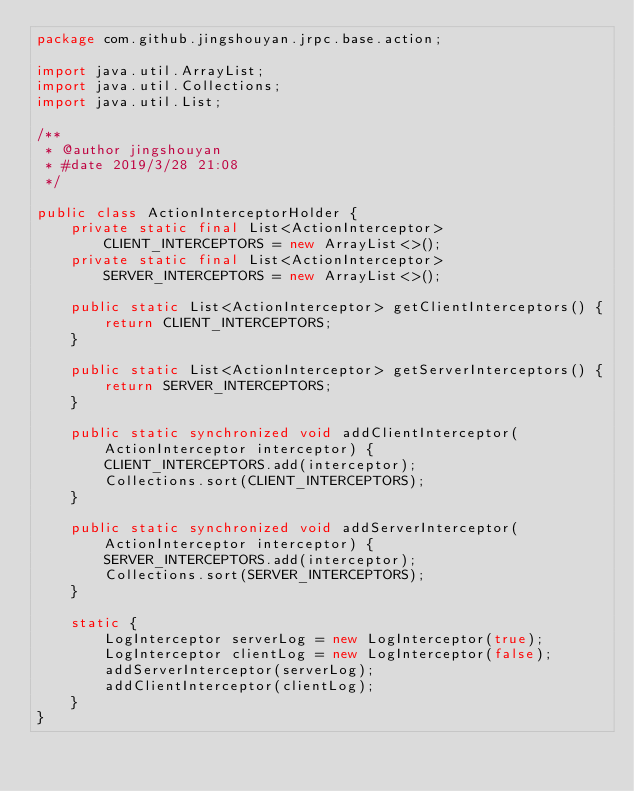Convert code to text. <code><loc_0><loc_0><loc_500><loc_500><_Java_>package com.github.jingshouyan.jrpc.base.action;

import java.util.ArrayList;
import java.util.Collections;
import java.util.List;

/**
 * @author jingshouyan
 * #date 2019/3/28 21:08
 */

public class ActionInterceptorHolder {
    private static final List<ActionInterceptor> CLIENT_INTERCEPTORS = new ArrayList<>();
    private static final List<ActionInterceptor> SERVER_INTERCEPTORS = new ArrayList<>();

    public static List<ActionInterceptor> getClientInterceptors() {
        return CLIENT_INTERCEPTORS;
    }

    public static List<ActionInterceptor> getServerInterceptors() {
        return SERVER_INTERCEPTORS;
    }

    public static synchronized void addClientInterceptor(ActionInterceptor interceptor) {
        CLIENT_INTERCEPTORS.add(interceptor);
        Collections.sort(CLIENT_INTERCEPTORS);
    }

    public static synchronized void addServerInterceptor(ActionInterceptor interceptor) {
        SERVER_INTERCEPTORS.add(interceptor);
        Collections.sort(SERVER_INTERCEPTORS);
    }

    static {
        LogInterceptor serverLog = new LogInterceptor(true);
        LogInterceptor clientLog = new LogInterceptor(false);
        addServerInterceptor(serverLog);
        addClientInterceptor(clientLog);
    }
}
</code> 